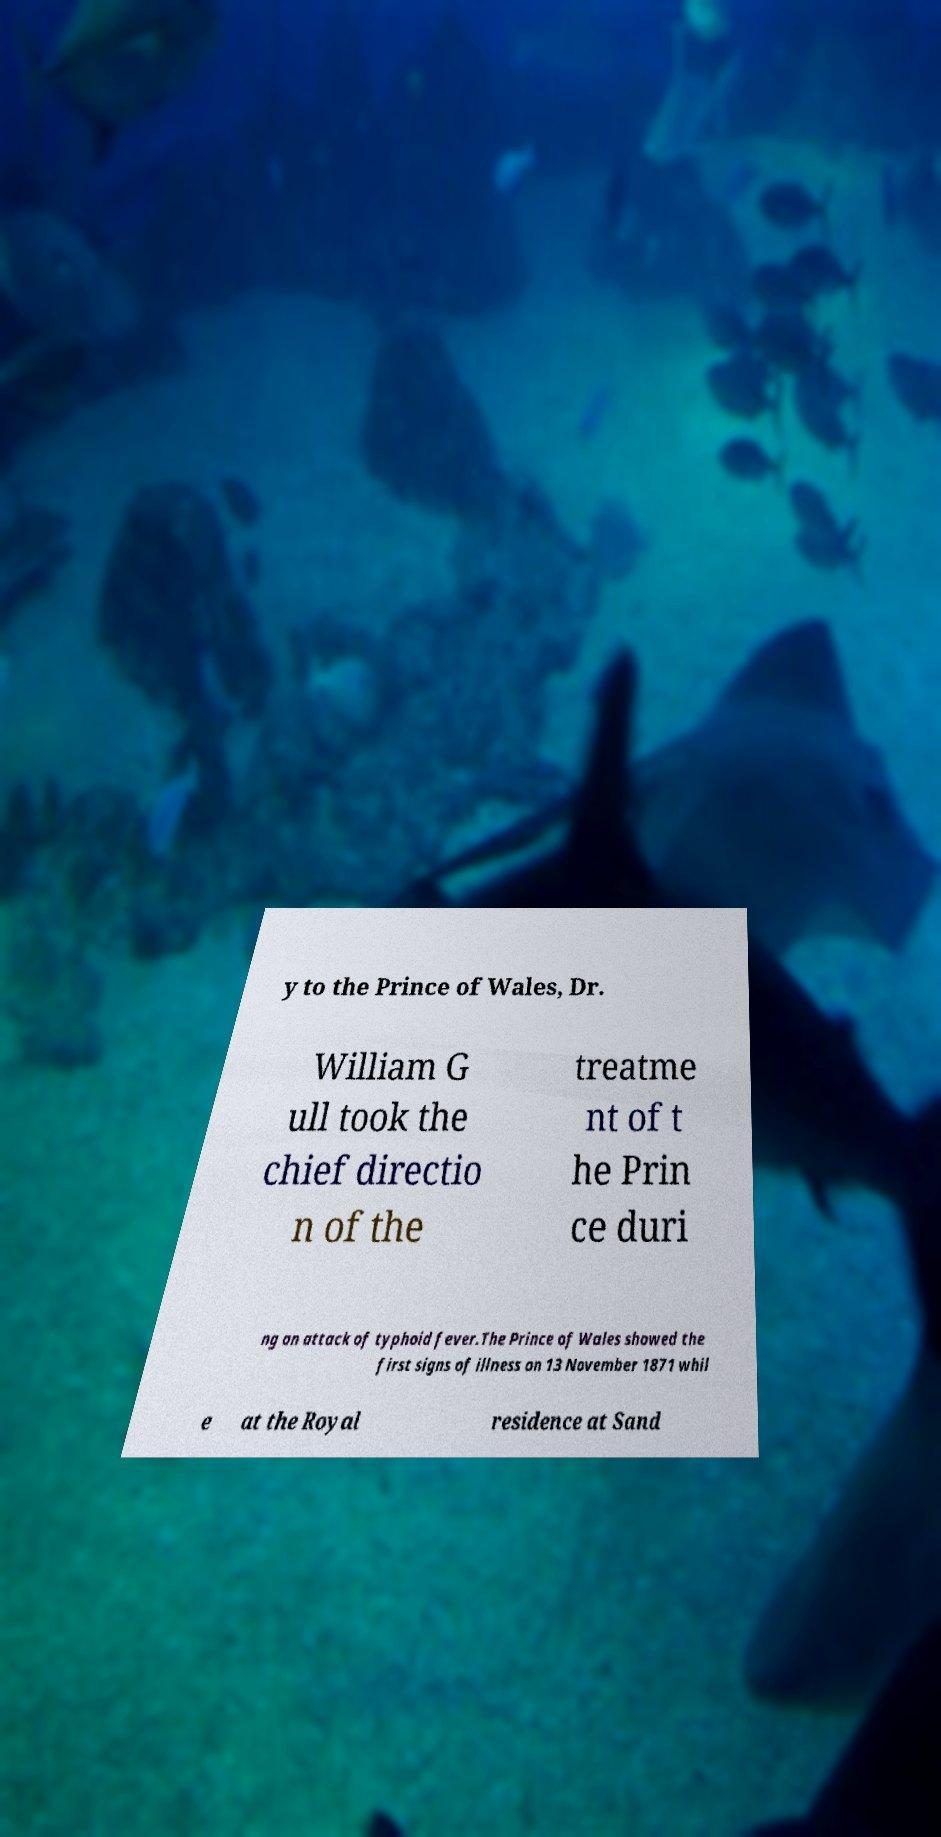Can you accurately transcribe the text from the provided image for me? y to the Prince of Wales, Dr. William G ull took the chief directio n of the treatme nt of t he Prin ce duri ng an attack of typhoid fever.The Prince of Wales showed the first signs of illness on 13 November 1871 whil e at the Royal residence at Sand 